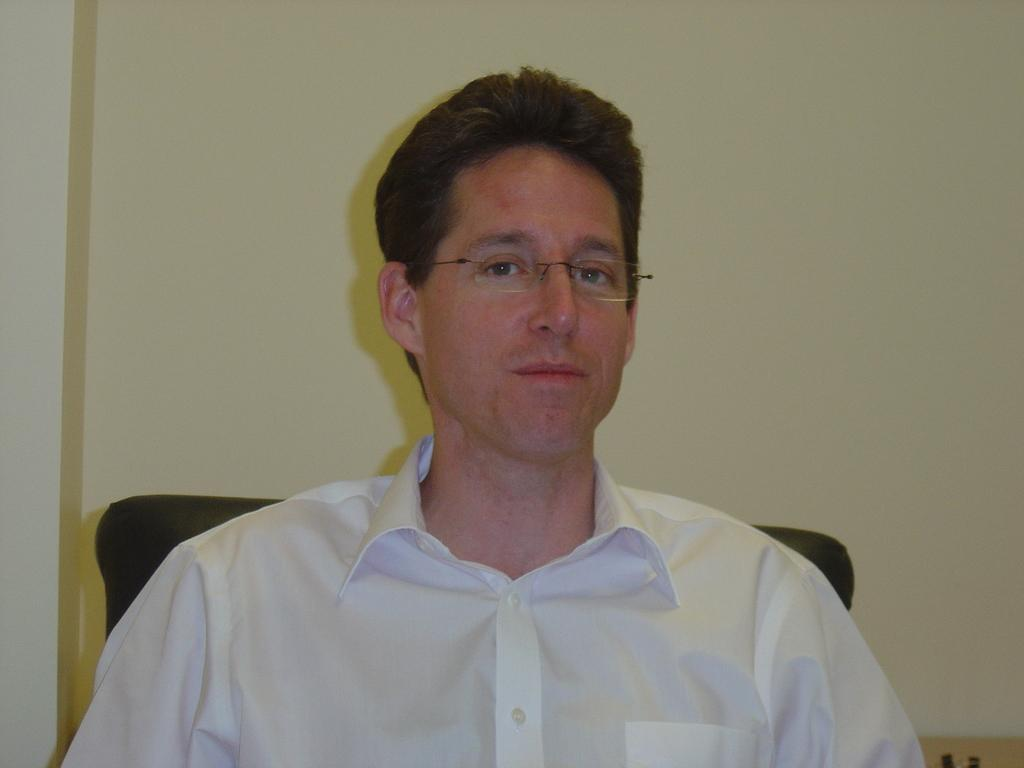What is the main subject of the image? There is a man in the image. What is the man doing in the image? The man is sitting in a chair. What can be seen in the background of the image? There is a wall in the background of the image. How many apples can be seen in the man's mouth in the image? There are no apples present in the image, and the man's mouth is not visible. 